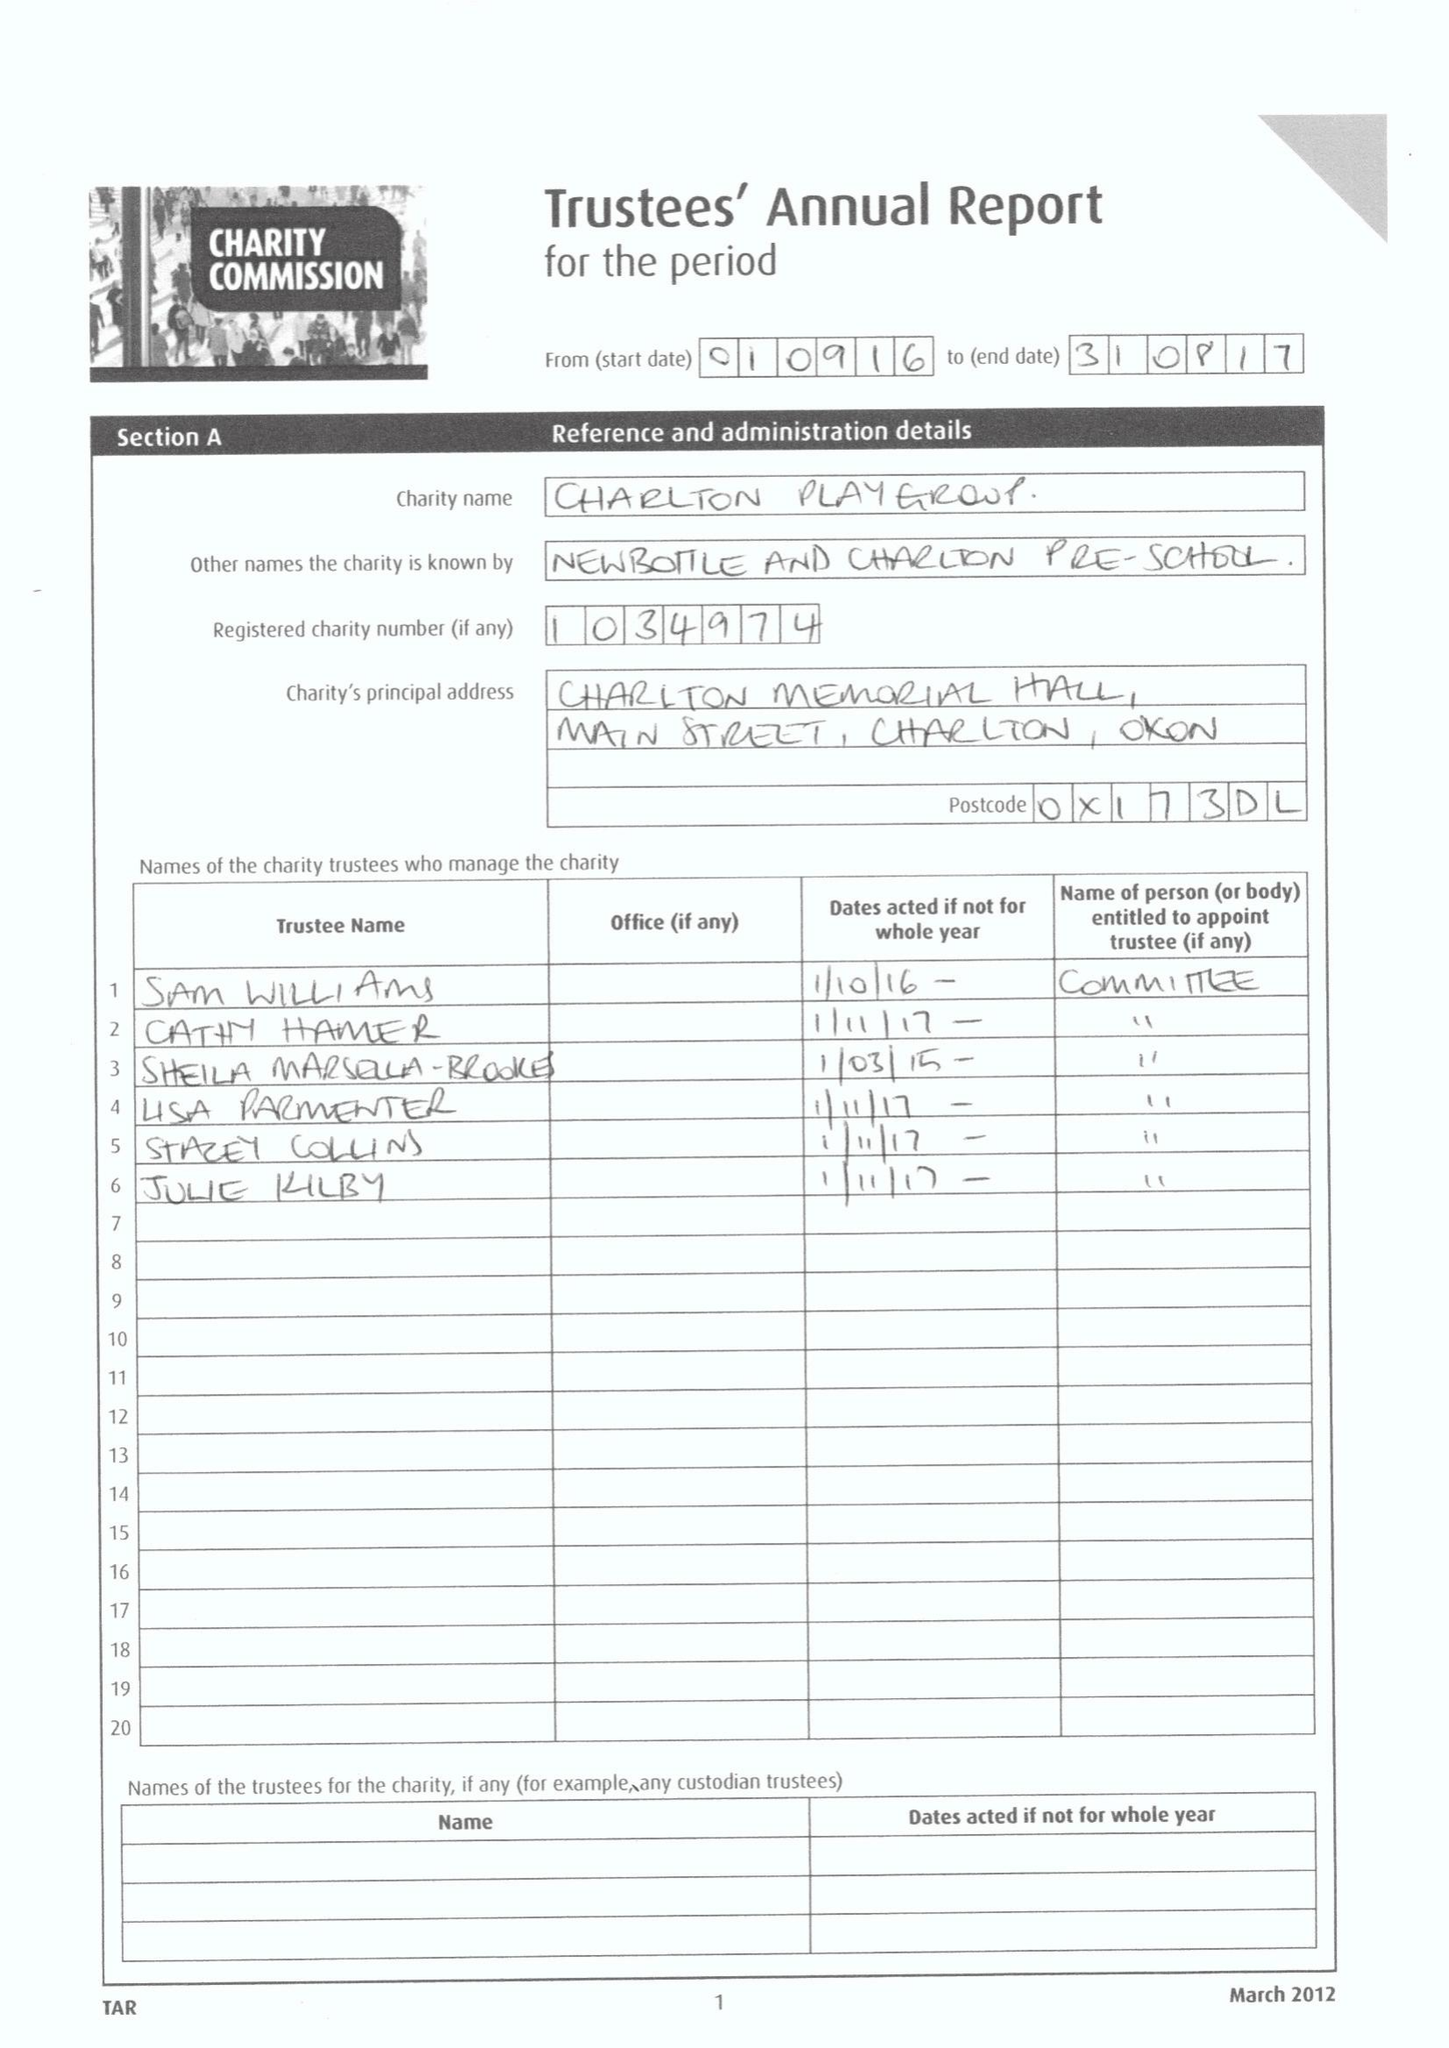What is the value for the report_date?
Answer the question using a single word or phrase. 2017-08-31 